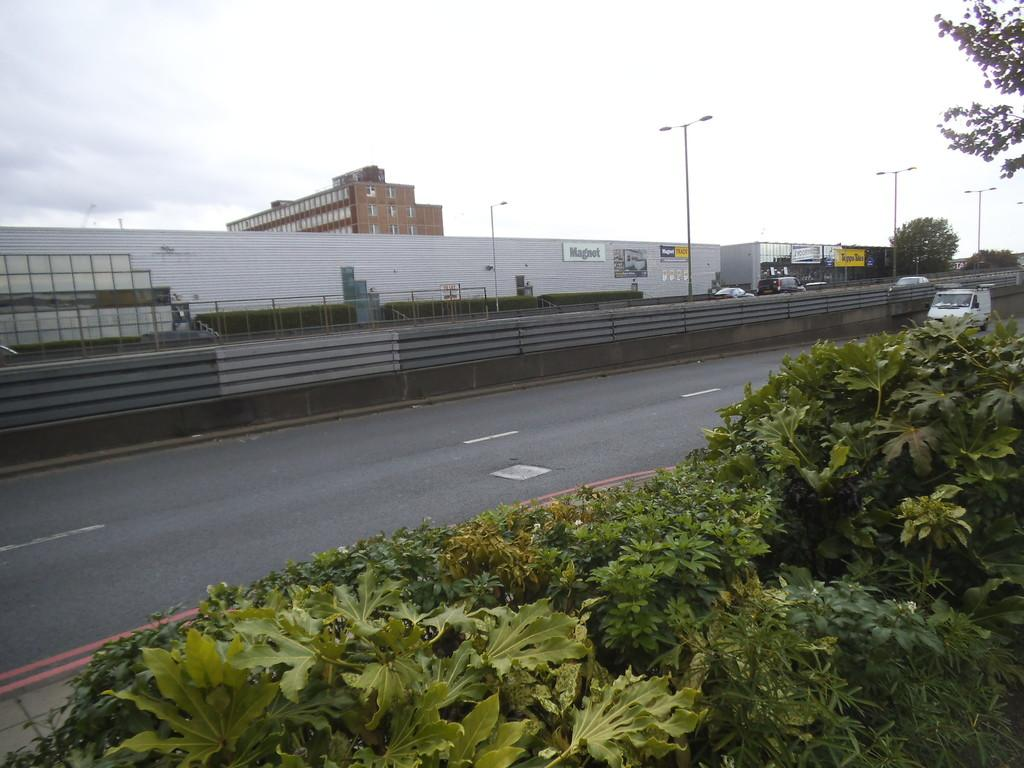What type of natural elements can be seen in the image? There are plants and trees in the image. What man-made structures are present in the image? There are poles, street lights, buildings, and boards in the image. What is the purpose of the poles in the image? The poles are likely supporting the street lights. What mode of transportation can be seen on the road in the image? There are vehicles on the road in the image. What is written on the boards in the image? There are words written on the boards in the image. Can you see a kitty driving a vehicle in the image? No, there is no kitty or vehicle being driven by a kitty in the image. How much sugar is in the trees in the image? There is no sugar present in the trees in the image; they are natural elements with no added substances. 